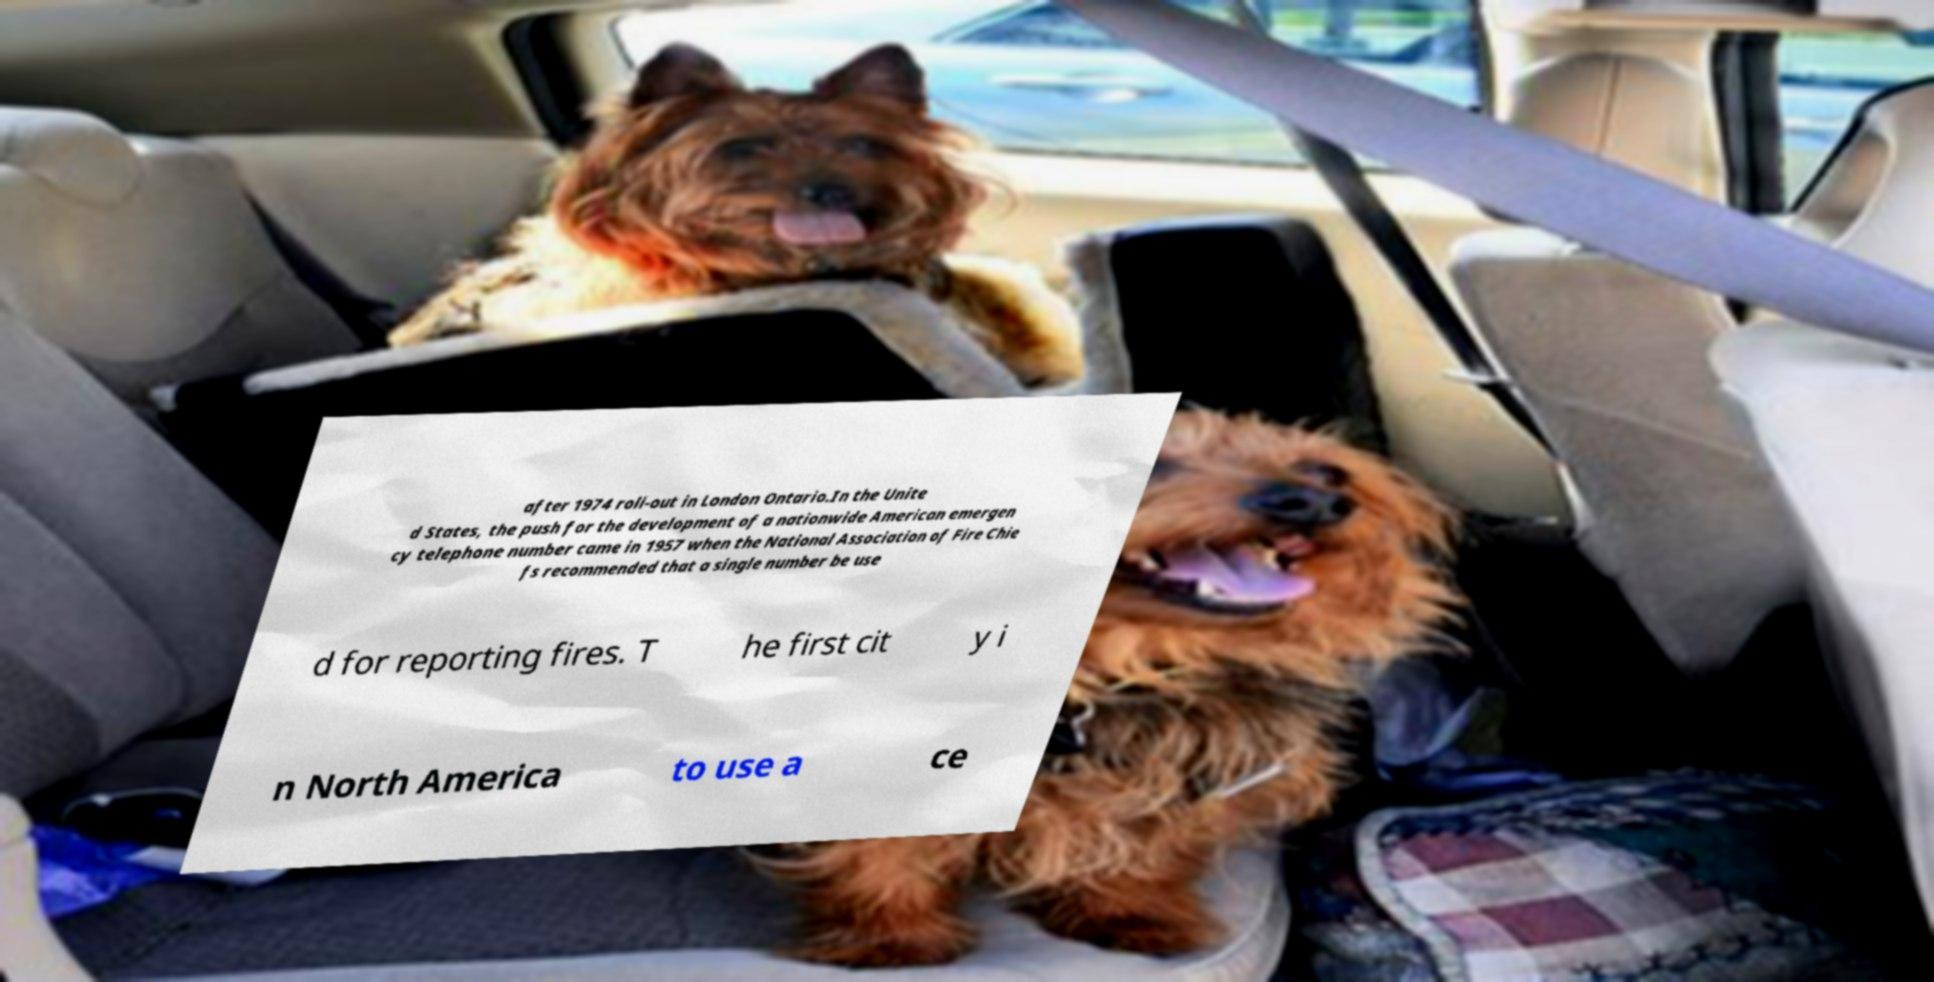Can you accurately transcribe the text from the provided image for me? after 1974 roll-out in London Ontario.In the Unite d States, the push for the development of a nationwide American emergen cy telephone number came in 1957 when the National Association of Fire Chie fs recommended that a single number be use d for reporting fires. T he first cit y i n North America to use a ce 